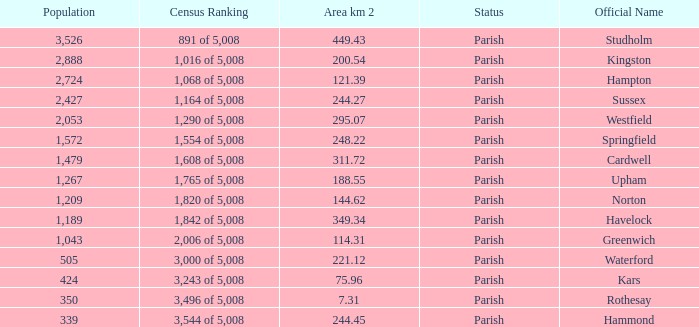What is the area in square kilometers of Studholm? 1.0. Help me parse the entirety of this table. {'header': ['Population', 'Census Ranking', 'Area km 2', 'Status', 'Official Name'], 'rows': [['3,526', '891 of 5,008', '449.43', 'Parish', 'Studholm'], ['2,888', '1,016 of 5,008', '200.54', 'Parish', 'Kingston'], ['2,724', '1,068 of 5,008', '121.39', 'Parish', 'Hampton'], ['2,427', '1,164 of 5,008', '244.27', 'Parish', 'Sussex'], ['2,053', '1,290 of 5,008', '295.07', 'Parish', 'Westfield'], ['1,572', '1,554 of 5,008', '248.22', 'Parish', 'Springfield'], ['1,479', '1,608 of 5,008', '311.72', 'Parish', 'Cardwell'], ['1,267', '1,765 of 5,008', '188.55', 'Parish', 'Upham'], ['1,209', '1,820 of 5,008', '144.62', 'Parish', 'Norton'], ['1,189', '1,842 of 5,008', '349.34', 'Parish', 'Havelock'], ['1,043', '2,006 of 5,008', '114.31', 'Parish', 'Greenwich'], ['505', '3,000 of 5,008', '221.12', 'Parish', 'Waterford'], ['424', '3,243 of 5,008', '75.96', 'Parish', 'Kars'], ['350', '3,496 of 5,008', '7.31', 'Parish', 'Rothesay'], ['339', '3,544 of 5,008', '244.45', 'Parish', 'Hammond']]} 